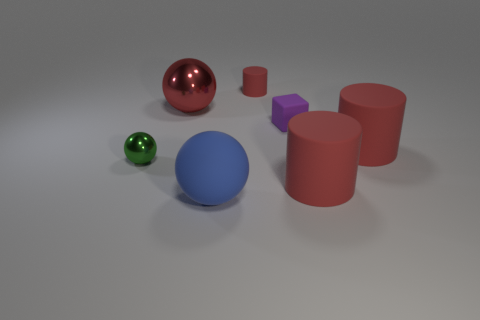There is a tiny thing in front of the small matte block that is in front of the red matte object that is to the left of the small purple matte object; what shape is it?
Your answer should be compact. Sphere. Is the shape of the big rubber object behind the green object the same as the red rubber object that is in front of the tiny green thing?
Make the answer very short. Yes. How many other things are the same material as the tiny green sphere?
Provide a succinct answer. 1. There is another small object that is the same material as the small purple thing; what shape is it?
Offer a very short reply. Cylinder. Does the red metal thing have the same size as the blue ball?
Provide a succinct answer. Yes. There is a red matte object left of the red cylinder in front of the green sphere; what is its size?
Your answer should be very brief. Small. There is a big metallic thing that is the same color as the small cylinder; what is its shape?
Offer a very short reply. Sphere. How many spheres are either large gray matte things or small purple things?
Your response must be concise. 0. Is the size of the blue sphere the same as the metal sphere that is behind the tiny green metal object?
Provide a succinct answer. Yes. Is the number of big cylinders to the left of the small ball greater than the number of balls?
Ensure brevity in your answer.  No. 